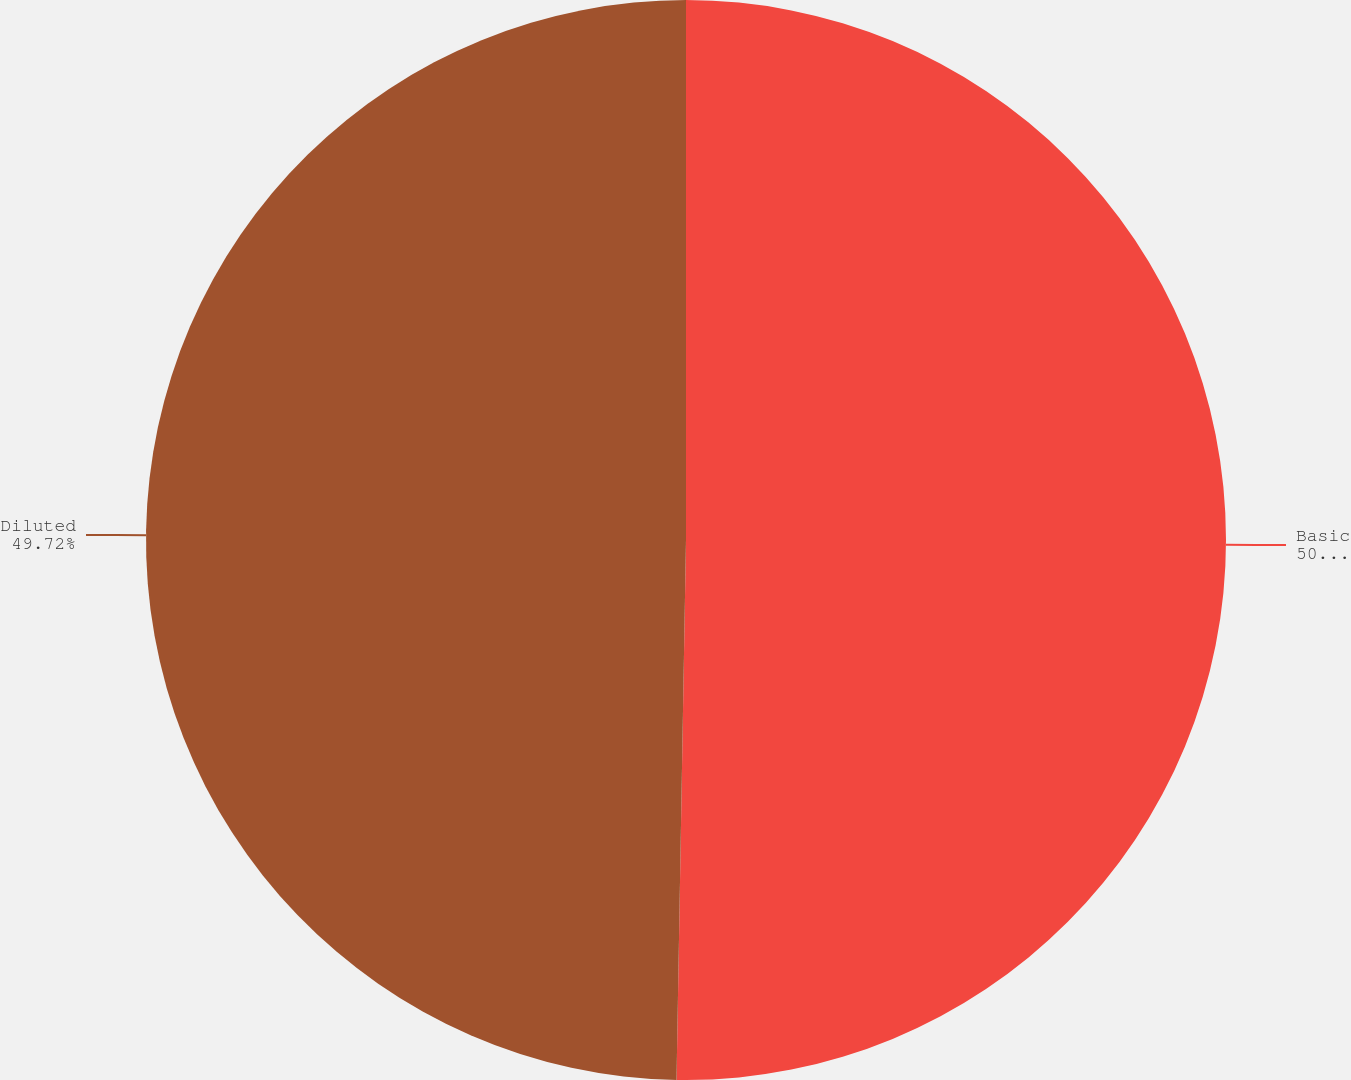<chart> <loc_0><loc_0><loc_500><loc_500><pie_chart><fcel>Basic<fcel>Diluted<nl><fcel>50.28%<fcel>49.72%<nl></chart> 